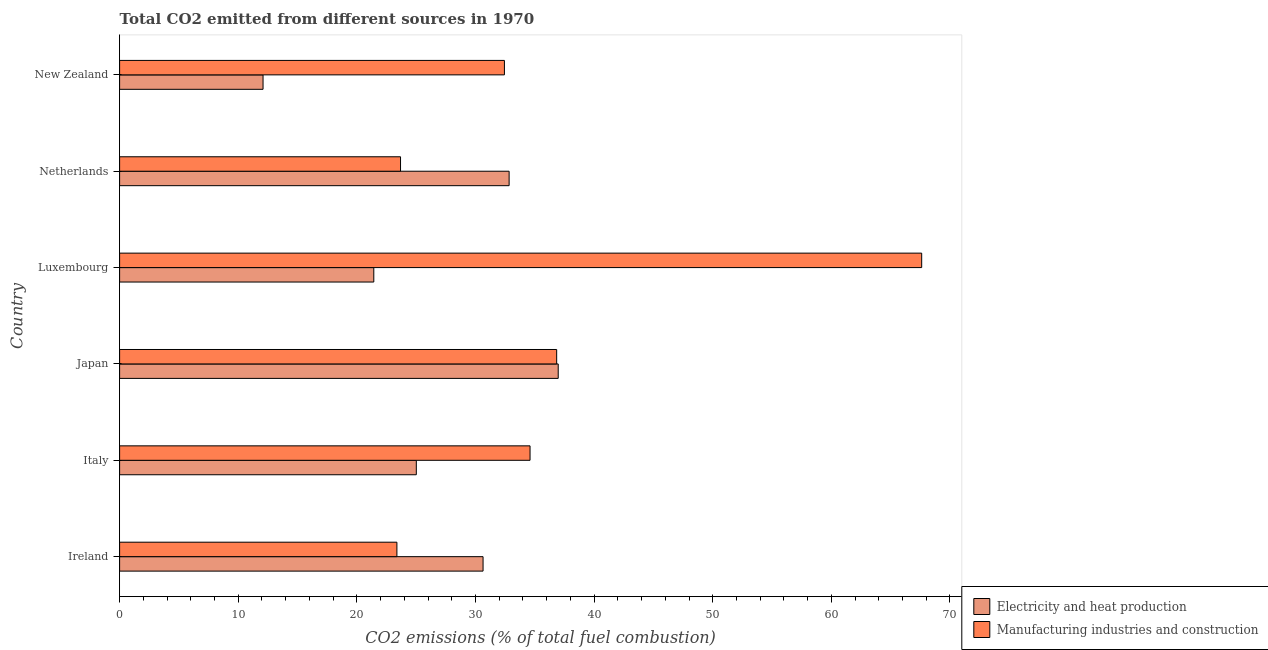How many different coloured bars are there?
Ensure brevity in your answer.  2. How many groups of bars are there?
Your answer should be very brief. 6. Are the number of bars per tick equal to the number of legend labels?
Provide a short and direct response. Yes. How many bars are there on the 5th tick from the bottom?
Ensure brevity in your answer.  2. What is the label of the 1st group of bars from the top?
Ensure brevity in your answer.  New Zealand. What is the co2 emissions due to manufacturing industries in Netherlands?
Provide a succinct answer. 23.68. Across all countries, what is the maximum co2 emissions due to manufacturing industries?
Your answer should be very brief. 67.62. Across all countries, what is the minimum co2 emissions due to electricity and heat production?
Give a very brief answer. 12.09. In which country was the co2 emissions due to manufacturing industries maximum?
Make the answer very short. Luxembourg. In which country was the co2 emissions due to electricity and heat production minimum?
Ensure brevity in your answer.  New Zealand. What is the total co2 emissions due to manufacturing industries in the graph?
Provide a succinct answer. 218.56. What is the difference between the co2 emissions due to manufacturing industries in Italy and that in Japan?
Your answer should be very brief. -2.25. What is the difference between the co2 emissions due to manufacturing industries in Ireland and the co2 emissions due to electricity and heat production in Italy?
Provide a succinct answer. -1.64. What is the average co2 emissions due to electricity and heat production per country?
Offer a very short reply. 26.5. What is the difference between the co2 emissions due to electricity and heat production and co2 emissions due to manufacturing industries in New Zealand?
Provide a succinct answer. -20.35. In how many countries, is the co2 emissions due to electricity and heat production greater than 36 %?
Keep it short and to the point. 1. What is the ratio of the co2 emissions due to electricity and heat production in Japan to that in New Zealand?
Provide a short and direct response. 3.06. What is the difference between the highest and the second highest co2 emissions due to manufacturing industries?
Your answer should be compact. 30.77. What is the difference between the highest and the lowest co2 emissions due to manufacturing industries?
Offer a terse response. 44.24. Is the sum of the co2 emissions due to electricity and heat production in Japan and Netherlands greater than the maximum co2 emissions due to manufacturing industries across all countries?
Offer a very short reply. Yes. What does the 1st bar from the top in Netherlands represents?
Your answer should be compact. Manufacturing industries and construction. What does the 1st bar from the bottom in New Zealand represents?
Offer a terse response. Electricity and heat production. How many bars are there?
Give a very brief answer. 12. How many countries are there in the graph?
Provide a succinct answer. 6. What is the difference between two consecutive major ticks on the X-axis?
Provide a short and direct response. 10. Are the values on the major ticks of X-axis written in scientific E-notation?
Your response must be concise. No. Does the graph contain grids?
Your answer should be compact. No. Where does the legend appear in the graph?
Give a very brief answer. Bottom right. How are the legend labels stacked?
Provide a short and direct response. Vertical. What is the title of the graph?
Give a very brief answer. Total CO2 emitted from different sources in 1970. What is the label or title of the X-axis?
Give a very brief answer. CO2 emissions (% of total fuel combustion). What is the CO2 emissions (% of total fuel combustion) in Electricity and heat production in Ireland?
Give a very brief answer. 30.64. What is the CO2 emissions (% of total fuel combustion) in Manufacturing industries and construction in Ireland?
Make the answer very short. 23.38. What is the CO2 emissions (% of total fuel combustion) of Electricity and heat production in Italy?
Make the answer very short. 25.01. What is the CO2 emissions (% of total fuel combustion) of Manufacturing industries and construction in Italy?
Give a very brief answer. 34.6. What is the CO2 emissions (% of total fuel combustion) of Electricity and heat production in Japan?
Offer a very short reply. 36.98. What is the CO2 emissions (% of total fuel combustion) of Manufacturing industries and construction in Japan?
Provide a short and direct response. 36.85. What is the CO2 emissions (% of total fuel combustion) in Electricity and heat production in Luxembourg?
Provide a short and direct response. 21.43. What is the CO2 emissions (% of total fuel combustion) in Manufacturing industries and construction in Luxembourg?
Offer a very short reply. 67.62. What is the CO2 emissions (% of total fuel combustion) in Electricity and heat production in Netherlands?
Offer a terse response. 32.84. What is the CO2 emissions (% of total fuel combustion) of Manufacturing industries and construction in Netherlands?
Offer a terse response. 23.68. What is the CO2 emissions (% of total fuel combustion) in Electricity and heat production in New Zealand?
Make the answer very short. 12.09. What is the CO2 emissions (% of total fuel combustion) in Manufacturing industries and construction in New Zealand?
Offer a terse response. 32.44. Across all countries, what is the maximum CO2 emissions (% of total fuel combustion) of Electricity and heat production?
Make the answer very short. 36.98. Across all countries, what is the maximum CO2 emissions (% of total fuel combustion) of Manufacturing industries and construction?
Your answer should be compact. 67.62. Across all countries, what is the minimum CO2 emissions (% of total fuel combustion) in Electricity and heat production?
Offer a very short reply. 12.09. Across all countries, what is the minimum CO2 emissions (% of total fuel combustion) of Manufacturing industries and construction?
Your response must be concise. 23.38. What is the total CO2 emissions (% of total fuel combustion) in Electricity and heat production in the graph?
Offer a very short reply. 158.98. What is the total CO2 emissions (% of total fuel combustion) in Manufacturing industries and construction in the graph?
Keep it short and to the point. 218.56. What is the difference between the CO2 emissions (% of total fuel combustion) in Electricity and heat production in Ireland and that in Italy?
Your answer should be very brief. 5.63. What is the difference between the CO2 emissions (% of total fuel combustion) in Manufacturing industries and construction in Ireland and that in Italy?
Your answer should be very brief. -11.22. What is the difference between the CO2 emissions (% of total fuel combustion) of Electricity and heat production in Ireland and that in Japan?
Provide a short and direct response. -6.34. What is the difference between the CO2 emissions (% of total fuel combustion) of Manufacturing industries and construction in Ireland and that in Japan?
Provide a short and direct response. -13.47. What is the difference between the CO2 emissions (% of total fuel combustion) of Electricity and heat production in Ireland and that in Luxembourg?
Your response must be concise. 9.21. What is the difference between the CO2 emissions (% of total fuel combustion) of Manufacturing industries and construction in Ireland and that in Luxembourg?
Your answer should be compact. -44.24. What is the difference between the CO2 emissions (% of total fuel combustion) of Electricity and heat production in Ireland and that in Netherlands?
Ensure brevity in your answer.  -2.2. What is the difference between the CO2 emissions (% of total fuel combustion) in Manufacturing industries and construction in Ireland and that in Netherlands?
Your answer should be compact. -0.31. What is the difference between the CO2 emissions (% of total fuel combustion) of Electricity and heat production in Ireland and that in New Zealand?
Ensure brevity in your answer.  18.55. What is the difference between the CO2 emissions (% of total fuel combustion) of Manufacturing industries and construction in Ireland and that in New Zealand?
Keep it short and to the point. -9.06. What is the difference between the CO2 emissions (% of total fuel combustion) in Electricity and heat production in Italy and that in Japan?
Your response must be concise. -11.96. What is the difference between the CO2 emissions (% of total fuel combustion) in Manufacturing industries and construction in Italy and that in Japan?
Your response must be concise. -2.25. What is the difference between the CO2 emissions (% of total fuel combustion) of Electricity and heat production in Italy and that in Luxembourg?
Your answer should be very brief. 3.58. What is the difference between the CO2 emissions (% of total fuel combustion) of Manufacturing industries and construction in Italy and that in Luxembourg?
Offer a terse response. -33.01. What is the difference between the CO2 emissions (% of total fuel combustion) in Electricity and heat production in Italy and that in Netherlands?
Your answer should be very brief. -7.82. What is the difference between the CO2 emissions (% of total fuel combustion) in Manufacturing industries and construction in Italy and that in Netherlands?
Your response must be concise. 10.92. What is the difference between the CO2 emissions (% of total fuel combustion) in Electricity and heat production in Italy and that in New Zealand?
Offer a terse response. 12.92. What is the difference between the CO2 emissions (% of total fuel combustion) in Manufacturing industries and construction in Italy and that in New Zealand?
Provide a short and direct response. 2.16. What is the difference between the CO2 emissions (% of total fuel combustion) in Electricity and heat production in Japan and that in Luxembourg?
Keep it short and to the point. 15.55. What is the difference between the CO2 emissions (% of total fuel combustion) in Manufacturing industries and construction in Japan and that in Luxembourg?
Offer a very short reply. -30.77. What is the difference between the CO2 emissions (% of total fuel combustion) in Electricity and heat production in Japan and that in Netherlands?
Your response must be concise. 4.14. What is the difference between the CO2 emissions (% of total fuel combustion) in Manufacturing industries and construction in Japan and that in Netherlands?
Ensure brevity in your answer.  13.16. What is the difference between the CO2 emissions (% of total fuel combustion) in Electricity and heat production in Japan and that in New Zealand?
Provide a succinct answer. 24.88. What is the difference between the CO2 emissions (% of total fuel combustion) in Manufacturing industries and construction in Japan and that in New Zealand?
Give a very brief answer. 4.4. What is the difference between the CO2 emissions (% of total fuel combustion) of Electricity and heat production in Luxembourg and that in Netherlands?
Give a very brief answer. -11.41. What is the difference between the CO2 emissions (% of total fuel combustion) of Manufacturing industries and construction in Luxembourg and that in Netherlands?
Make the answer very short. 43.93. What is the difference between the CO2 emissions (% of total fuel combustion) of Electricity and heat production in Luxembourg and that in New Zealand?
Provide a succinct answer. 9.34. What is the difference between the CO2 emissions (% of total fuel combustion) in Manufacturing industries and construction in Luxembourg and that in New Zealand?
Provide a succinct answer. 35.17. What is the difference between the CO2 emissions (% of total fuel combustion) in Electricity and heat production in Netherlands and that in New Zealand?
Your answer should be very brief. 20.74. What is the difference between the CO2 emissions (% of total fuel combustion) of Manufacturing industries and construction in Netherlands and that in New Zealand?
Your answer should be compact. -8.76. What is the difference between the CO2 emissions (% of total fuel combustion) in Electricity and heat production in Ireland and the CO2 emissions (% of total fuel combustion) in Manufacturing industries and construction in Italy?
Give a very brief answer. -3.96. What is the difference between the CO2 emissions (% of total fuel combustion) of Electricity and heat production in Ireland and the CO2 emissions (% of total fuel combustion) of Manufacturing industries and construction in Japan?
Ensure brevity in your answer.  -6.21. What is the difference between the CO2 emissions (% of total fuel combustion) of Electricity and heat production in Ireland and the CO2 emissions (% of total fuel combustion) of Manufacturing industries and construction in Luxembourg?
Keep it short and to the point. -36.98. What is the difference between the CO2 emissions (% of total fuel combustion) of Electricity and heat production in Ireland and the CO2 emissions (% of total fuel combustion) of Manufacturing industries and construction in Netherlands?
Your response must be concise. 6.96. What is the difference between the CO2 emissions (% of total fuel combustion) of Electricity and heat production in Ireland and the CO2 emissions (% of total fuel combustion) of Manufacturing industries and construction in New Zealand?
Ensure brevity in your answer.  -1.8. What is the difference between the CO2 emissions (% of total fuel combustion) in Electricity and heat production in Italy and the CO2 emissions (% of total fuel combustion) in Manufacturing industries and construction in Japan?
Your answer should be compact. -11.83. What is the difference between the CO2 emissions (% of total fuel combustion) of Electricity and heat production in Italy and the CO2 emissions (% of total fuel combustion) of Manufacturing industries and construction in Luxembourg?
Offer a terse response. -42.6. What is the difference between the CO2 emissions (% of total fuel combustion) in Electricity and heat production in Italy and the CO2 emissions (% of total fuel combustion) in Manufacturing industries and construction in Netherlands?
Offer a terse response. 1.33. What is the difference between the CO2 emissions (% of total fuel combustion) of Electricity and heat production in Italy and the CO2 emissions (% of total fuel combustion) of Manufacturing industries and construction in New Zealand?
Offer a very short reply. -7.43. What is the difference between the CO2 emissions (% of total fuel combustion) in Electricity and heat production in Japan and the CO2 emissions (% of total fuel combustion) in Manufacturing industries and construction in Luxembourg?
Give a very brief answer. -30.64. What is the difference between the CO2 emissions (% of total fuel combustion) of Electricity and heat production in Japan and the CO2 emissions (% of total fuel combustion) of Manufacturing industries and construction in Netherlands?
Your response must be concise. 13.29. What is the difference between the CO2 emissions (% of total fuel combustion) in Electricity and heat production in Japan and the CO2 emissions (% of total fuel combustion) in Manufacturing industries and construction in New Zealand?
Provide a succinct answer. 4.53. What is the difference between the CO2 emissions (% of total fuel combustion) of Electricity and heat production in Luxembourg and the CO2 emissions (% of total fuel combustion) of Manufacturing industries and construction in Netherlands?
Make the answer very short. -2.25. What is the difference between the CO2 emissions (% of total fuel combustion) of Electricity and heat production in Luxembourg and the CO2 emissions (% of total fuel combustion) of Manufacturing industries and construction in New Zealand?
Provide a succinct answer. -11.01. What is the difference between the CO2 emissions (% of total fuel combustion) in Electricity and heat production in Netherlands and the CO2 emissions (% of total fuel combustion) in Manufacturing industries and construction in New Zealand?
Offer a terse response. 0.4. What is the average CO2 emissions (% of total fuel combustion) in Electricity and heat production per country?
Your response must be concise. 26.5. What is the average CO2 emissions (% of total fuel combustion) in Manufacturing industries and construction per country?
Your answer should be compact. 36.43. What is the difference between the CO2 emissions (% of total fuel combustion) in Electricity and heat production and CO2 emissions (% of total fuel combustion) in Manufacturing industries and construction in Ireland?
Offer a very short reply. 7.26. What is the difference between the CO2 emissions (% of total fuel combustion) of Electricity and heat production and CO2 emissions (% of total fuel combustion) of Manufacturing industries and construction in Italy?
Make the answer very short. -9.59. What is the difference between the CO2 emissions (% of total fuel combustion) of Electricity and heat production and CO2 emissions (% of total fuel combustion) of Manufacturing industries and construction in Japan?
Make the answer very short. 0.13. What is the difference between the CO2 emissions (% of total fuel combustion) in Electricity and heat production and CO2 emissions (% of total fuel combustion) in Manufacturing industries and construction in Luxembourg?
Offer a terse response. -46.19. What is the difference between the CO2 emissions (% of total fuel combustion) in Electricity and heat production and CO2 emissions (% of total fuel combustion) in Manufacturing industries and construction in Netherlands?
Offer a very short reply. 9.15. What is the difference between the CO2 emissions (% of total fuel combustion) in Electricity and heat production and CO2 emissions (% of total fuel combustion) in Manufacturing industries and construction in New Zealand?
Offer a very short reply. -20.35. What is the ratio of the CO2 emissions (% of total fuel combustion) in Electricity and heat production in Ireland to that in Italy?
Ensure brevity in your answer.  1.23. What is the ratio of the CO2 emissions (% of total fuel combustion) of Manufacturing industries and construction in Ireland to that in Italy?
Provide a short and direct response. 0.68. What is the ratio of the CO2 emissions (% of total fuel combustion) of Electricity and heat production in Ireland to that in Japan?
Make the answer very short. 0.83. What is the ratio of the CO2 emissions (% of total fuel combustion) in Manufacturing industries and construction in Ireland to that in Japan?
Offer a very short reply. 0.63. What is the ratio of the CO2 emissions (% of total fuel combustion) of Electricity and heat production in Ireland to that in Luxembourg?
Offer a terse response. 1.43. What is the ratio of the CO2 emissions (% of total fuel combustion) of Manufacturing industries and construction in Ireland to that in Luxembourg?
Make the answer very short. 0.35. What is the ratio of the CO2 emissions (% of total fuel combustion) in Electricity and heat production in Ireland to that in Netherlands?
Provide a short and direct response. 0.93. What is the ratio of the CO2 emissions (% of total fuel combustion) of Manufacturing industries and construction in Ireland to that in Netherlands?
Make the answer very short. 0.99. What is the ratio of the CO2 emissions (% of total fuel combustion) of Electricity and heat production in Ireland to that in New Zealand?
Give a very brief answer. 2.53. What is the ratio of the CO2 emissions (% of total fuel combustion) in Manufacturing industries and construction in Ireland to that in New Zealand?
Your answer should be compact. 0.72. What is the ratio of the CO2 emissions (% of total fuel combustion) of Electricity and heat production in Italy to that in Japan?
Ensure brevity in your answer.  0.68. What is the ratio of the CO2 emissions (% of total fuel combustion) of Manufacturing industries and construction in Italy to that in Japan?
Give a very brief answer. 0.94. What is the ratio of the CO2 emissions (% of total fuel combustion) in Electricity and heat production in Italy to that in Luxembourg?
Provide a short and direct response. 1.17. What is the ratio of the CO2 emissions (% of total fuel combustion) in Manufacturing industries and construction in Italy to that in Luxembourg?
Ensure brevity in your answer.  0.51. What is the ratio of the CO2 emissions (% of total fuel combustion) of Electricity and heat production in Italy to that in Netherlands?
Give a very brief answer. 0.76. What is the ratio of the CO2 emissions (% of total fuel combustion) of Manufacturing industries and construction in Italy to that in Netherlands?
Offer a very short reply. 1.46. What is the ratio of the CO2 emissions (% of total fuel combustion) in Electricity and heat production in Italy to that in New Zealand?
Ensure brevity in your answer.  2.07. What is the ratio of the CO2 emissions (% of total fuel combustion) of Manufacturing industries and construction in Italy to that in New Zealand?
Your answer should be very brief. 1.07. What is the ratio of the CO2 emissions (% of total fuel combustion) of Electricity and heat production in Japan to that in Luxembourg?
Your answer should be compact. 1.73. What is the ratio of the CO2 emissions (% of total fuel combustion) in Manufacturing industries and construction in Japan to that in Luxembourg?
Make the answer very short. 0.54. What is the ratio of the CO2 emissions (% of total fuel combustion) of Electricity and heat production in Japan to that in Netherlands?
Offer a very short reply. 1.13. What is the ratio of the CO2 emissions (% of total fuel combustion) of Manufacturing industries and construction in Japan to that in Netherlands?
Offer a terse response. 1.56. What is the ratio of the CO2 emissions (% of total fuel combustion) in Electricity and heat production in Japan to that in New Zealand?
Provide a succinct answer. 3.06. What is the ratio of the CO2 emissions (% of total fuel combustion) of Manufacturing industries and construction in Japan to that in New Zealand?
Keep it short and to the point. 1.14. What is the ratio of the CO2 emissions (% of total fuel combustion) in Electricity and heat production in Luxembourg to that in Netherlands?
Offer a terse response. 0.65. What is the ratio of the CO2 emissions (% of total fuel combustion) in Manufacturing industries and construction in Luxembourg to that in Netherlands?
Give a very brief answer. 2.86. What is the ratio of the CO2 emissions (% of total fuel combustion) of Electricity and heat production in Luxembourg to that in New Zealand?
Offer a terse response. 1.77. What is the ratio of the CO2 emissions (% of total fuel combustion) in Manufacturing industries and construction in Luxembourg to that in New Zealand?
Give a very brief answer. 2.08. What is the ratio of the CO2 emissions (% of total fuel combustion) in Electricity and heat production in Netherlands to that in New Zealand?
Keep it short and to the point. 2.72. What is the ratio of the CO2 emissions (% of total fuel combustion) in Manufacturing industries and construction in Netherlands to that in New Zealand?
Keep it short and to the point. 0.73. What is the difference between the highest and the second highest CO2 emissions (% of total fuel combustion) of Electricity and heat production?
Keep it short and to the point. 4.14. What is the difference between the highest and the second highest CO2 emissions (% of total fuel combustion) in Manufacturing industries and construction?
Offer a very short reply. 30.77. What is the difference between the highest and the lowest CO2 emissions (% of total fuel combustion) of Electricity and heat production?
Provide a succinct answer. 24.88. What is the difference between the highest and the lowest CO2 emissions (% of total fuel combustion) of Manufacturing industries and construction?
Your answer should be very brief. 44.24. 